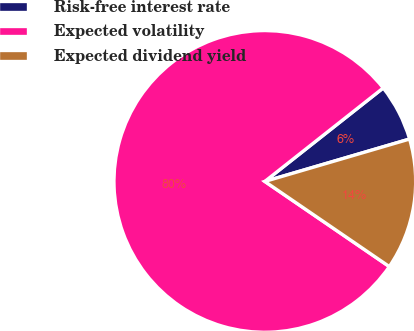<chart> <loc_0><loc_0><loc_500><loc_500><pie_chart><fcel>Risk-free interest rate<fcel>Expected volatility<fcel>Expected dividend yield<nl><fcel>6.1%<fcel>79.81%<fcel>14.08%<nl></chart> 